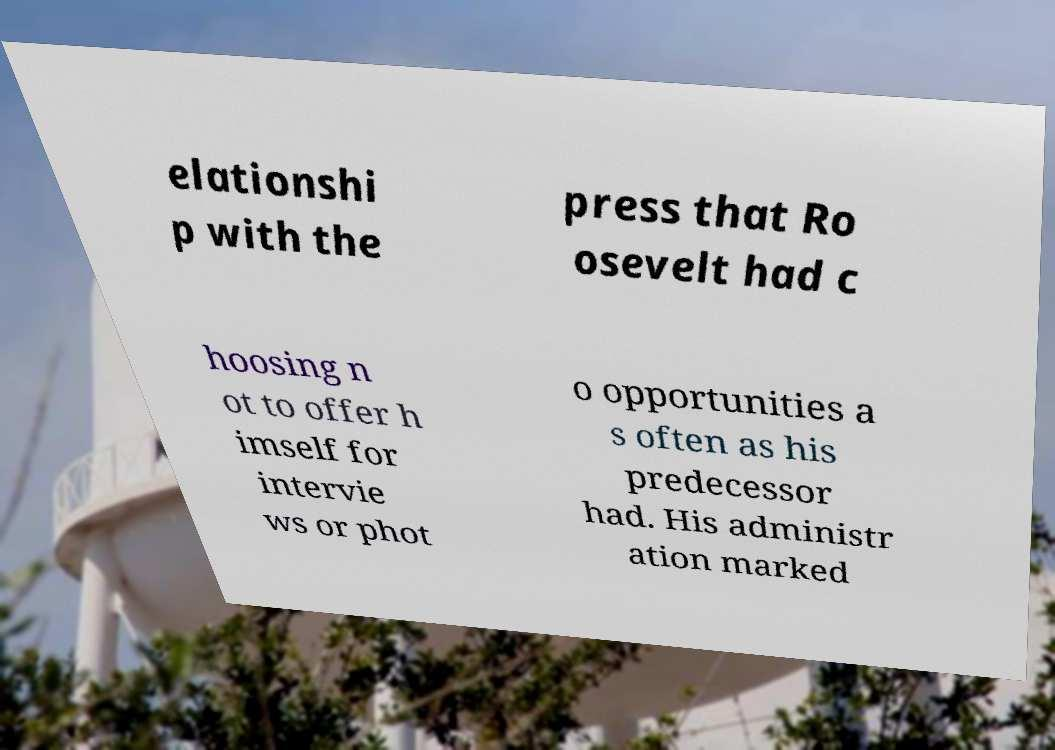There's text embedded in this image that I need extracted. Can you transcribe it verbatim? elationshi p with the press that Ro osevelt had c hoosing n ot to offer h imself for intervie ws or phot o opportunities a s often as his predecessor had. His administr ation marked 